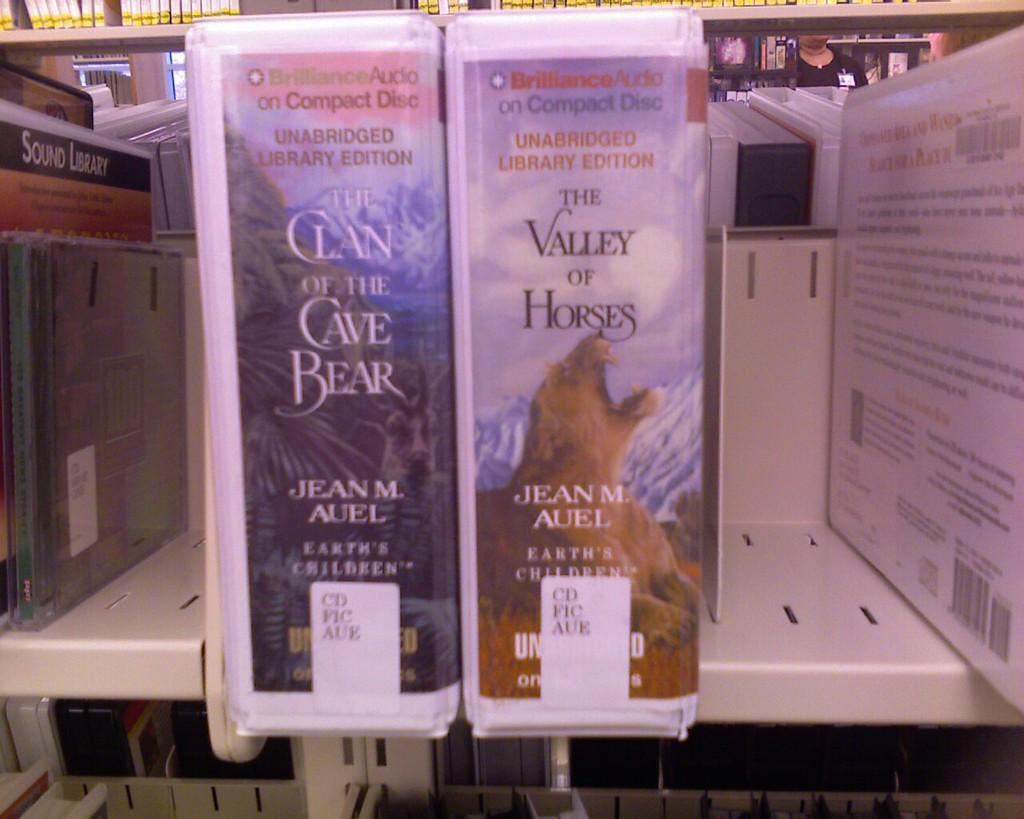<image>
Write a terse but informative summary of the picture. Advertisements for The Valley of Horses and The Clan of the Cave Bear on a store shelf. 